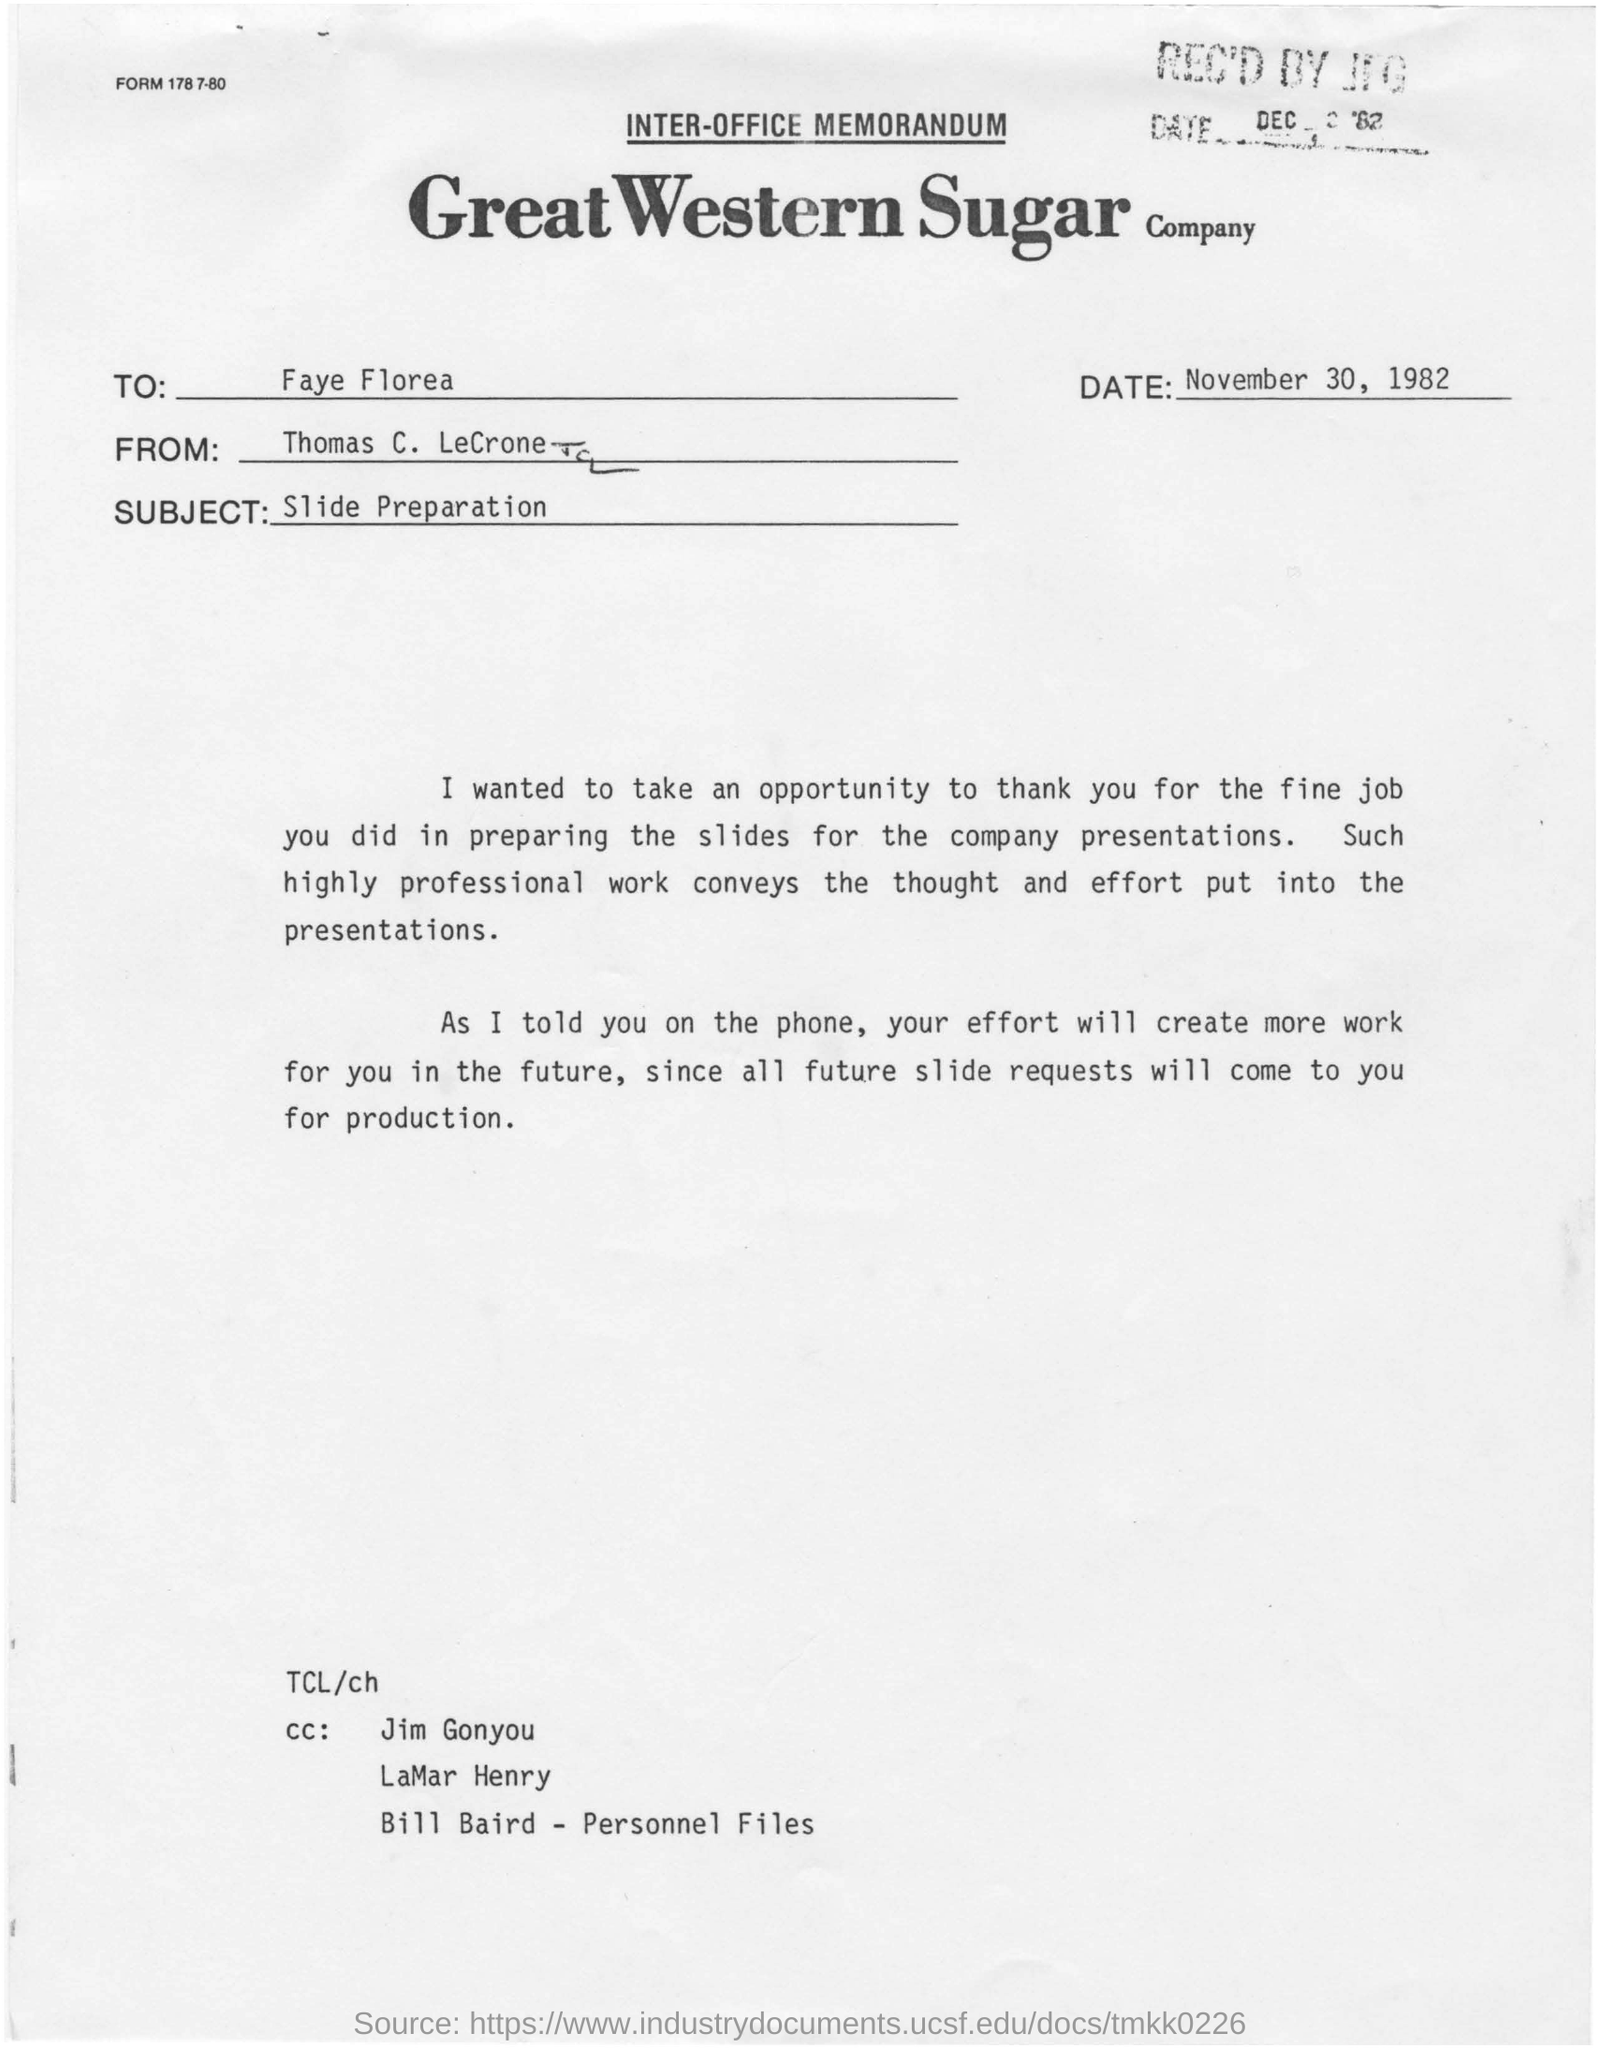Specify some key components in this picture. The memorandum is from Thomas C. LeCrone. The subject of the memorandum is the preparation of slides. The recipient of this memorandum is Faye Florea. The memorandum was dated on November 30, 1982. 